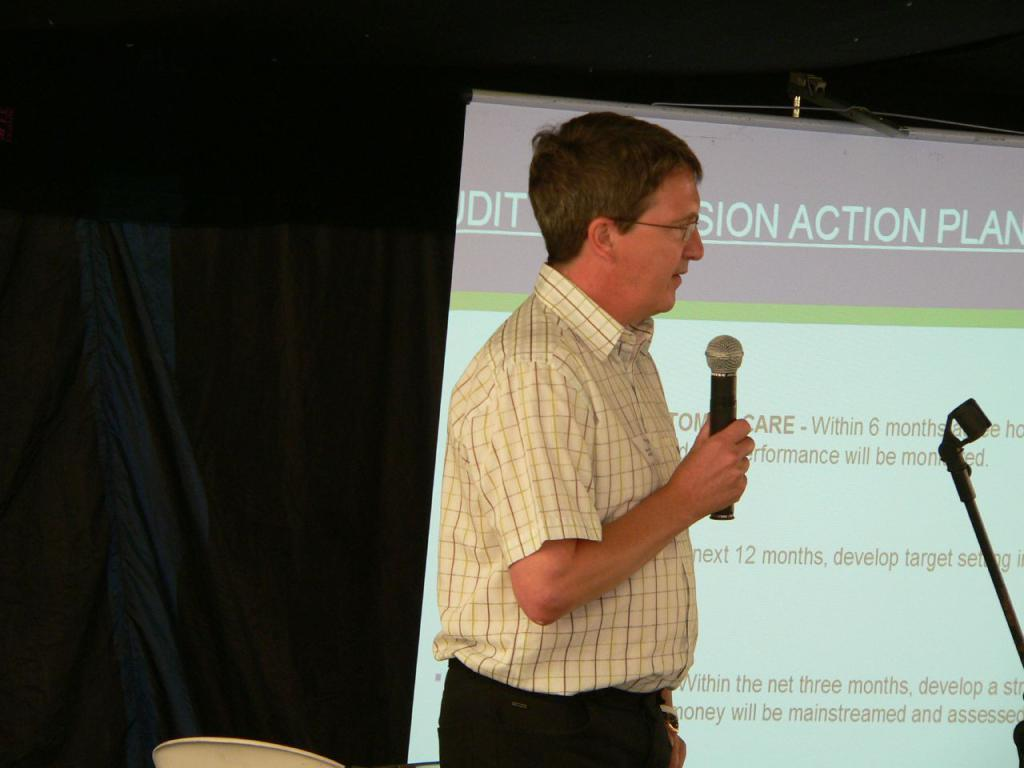What is the man in the image doing? The man is standing in the image and holding a mic. What can be seen behind the man? There is a curtain in the image. What is the man likely to use the mic for? The man might be using the mic for speaking or performing. What is present on the right side of the image? There is a stand on the right side of the image. What is displayed on the screen in the image? There is a display screen with text in the image. Can you tell me how many basins are visible in the image? There are no basins present in the image. What type of beast is standing next to the man in the image? There is no beast present in the image; only the man, mic, curtain, chair, display screen, and stand are visible. 